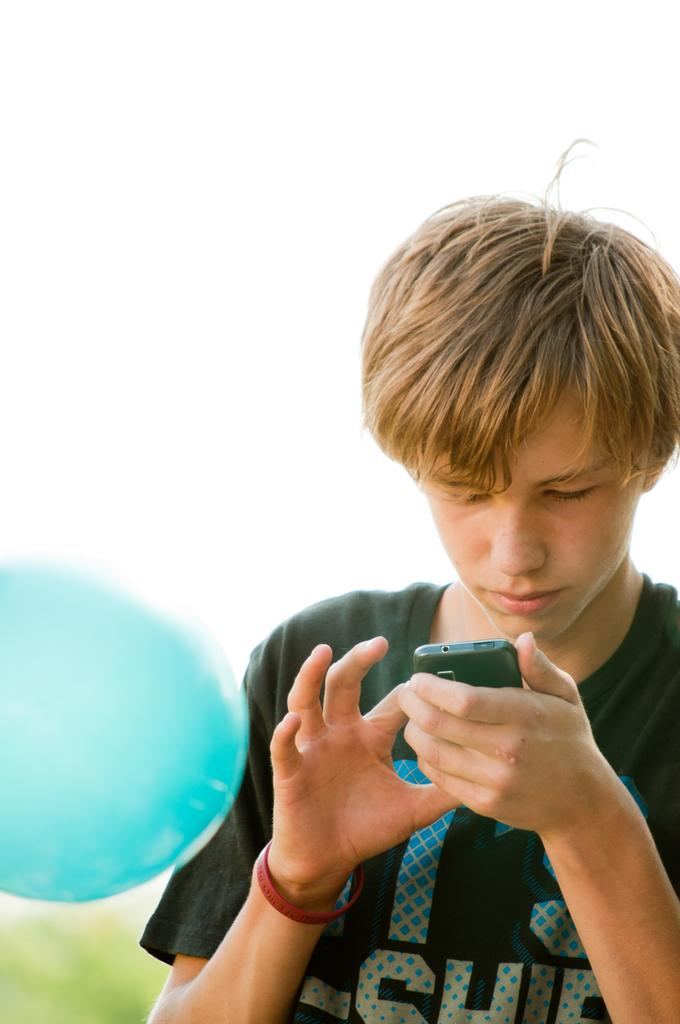What is the main subject of the image? There is a person in the image. What is the person holding in the image? The person is holding a mobile. Can you see any visible veins on the person's hand in the image? There is no information about the person's hand or veins in the image, so it cannot be determined. 